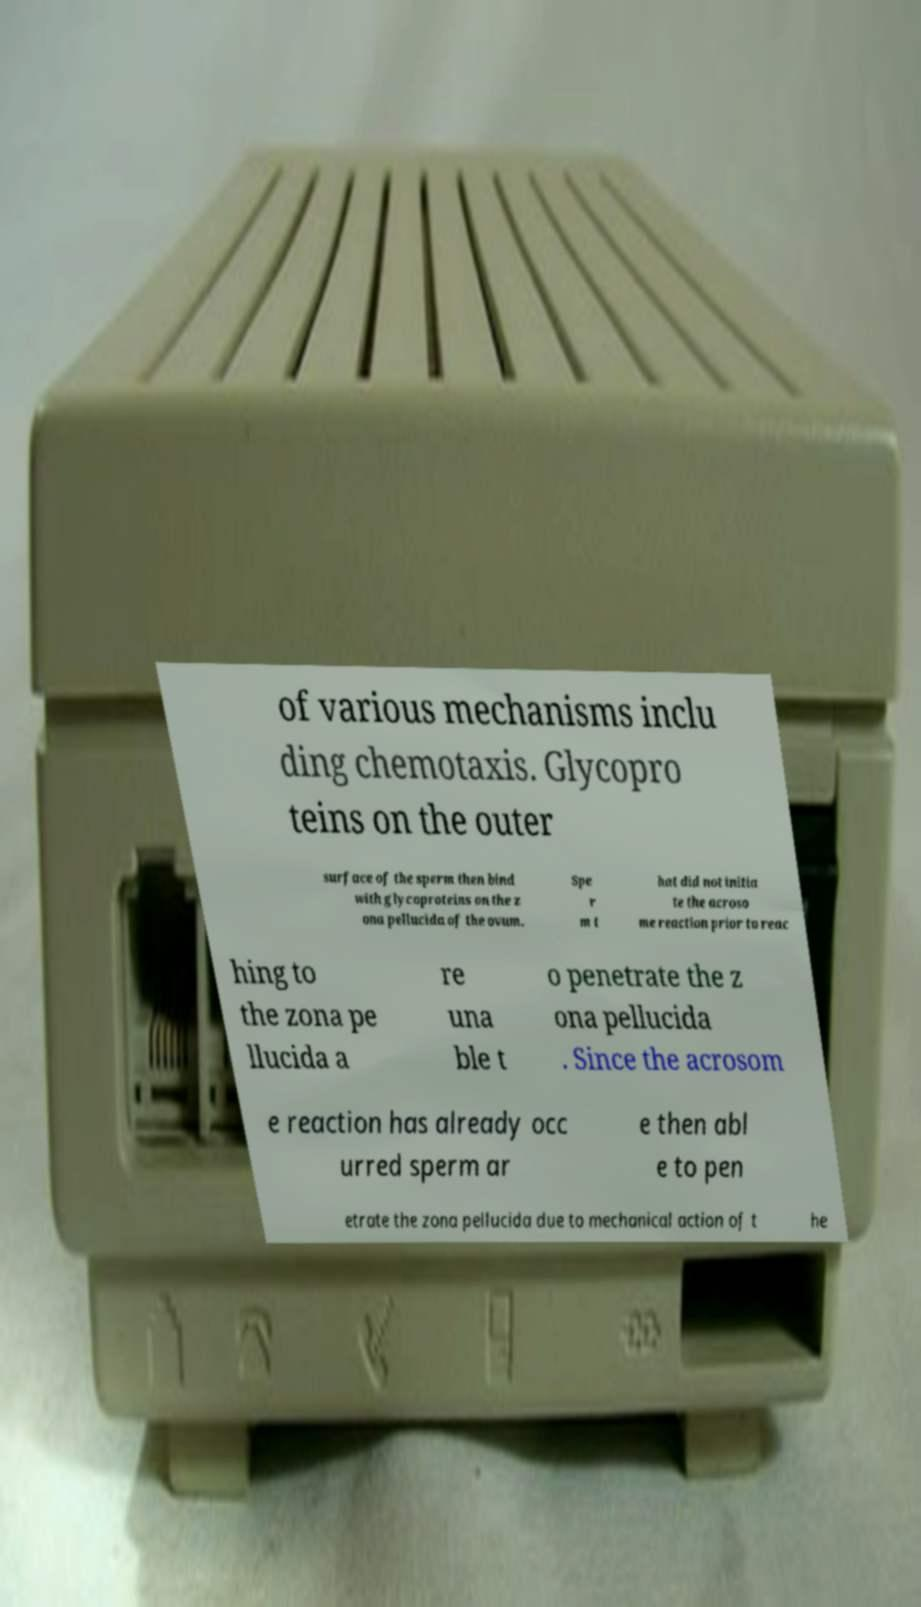Please read and relay the text visible in this image. What does it say? of various mechanisms inclu ding chemotaxis. Glycopro teins on the outer surface of the sperm then bind with glycoproteins on the z ona pellucida of the ovum. Spe r m t hat did not initia te the acroso me reaction prior to reac hing to the zona pe llucida a re una ble t o penetrate the z ona pellucida . Since the acrosom e reaction has already occ urred sperm ar e then abl e to pen etrate the zona pellucida due to mechanical action of t he 